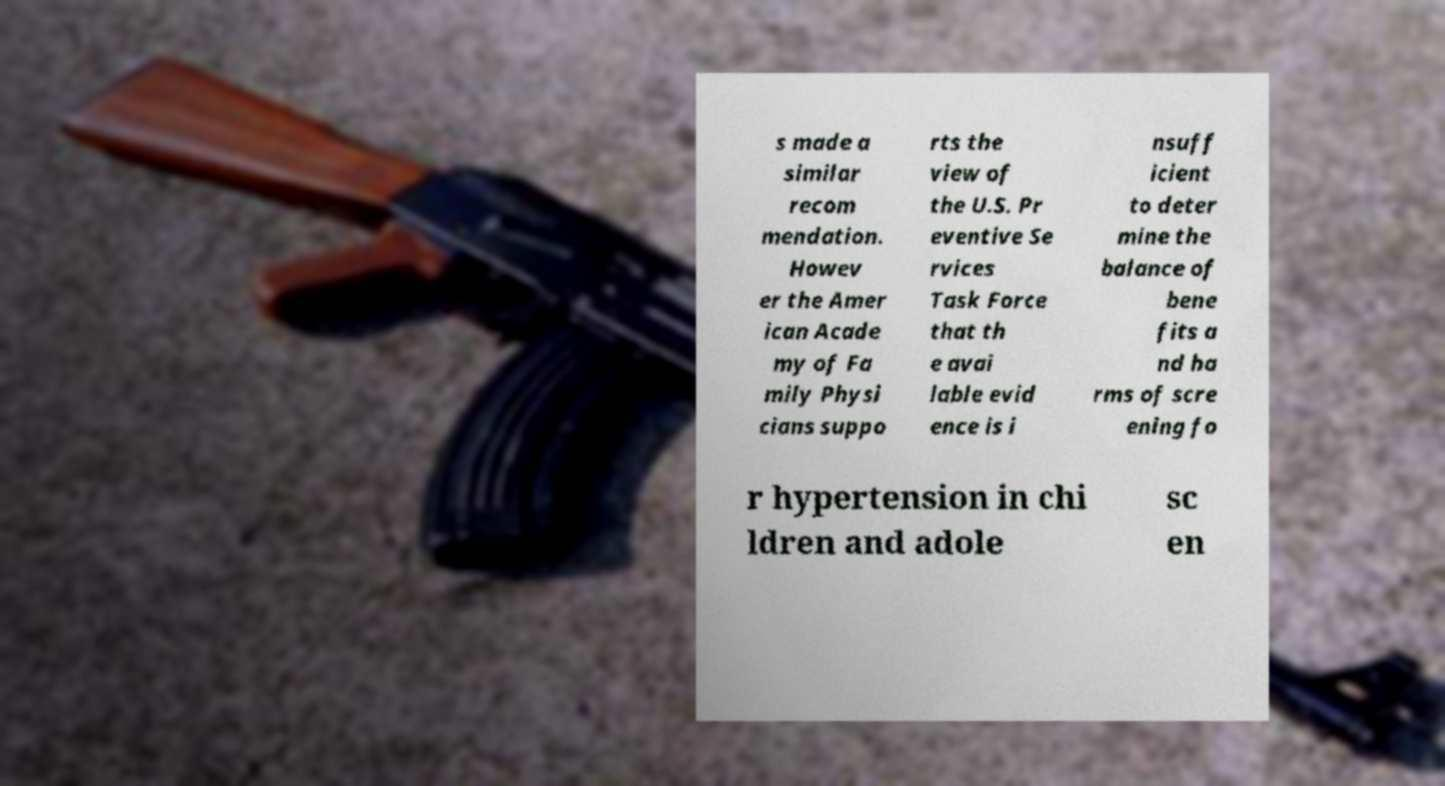Could you extract and type out the text from this image? s made a similar recom mendation. Howev er the Amer ican Acade my of Fa mily Physi cians suppo rts the view of the U.S. Pr eventive Se rvices Task Force that th e avai lable evid ence is i nsuff icient to deter mine the balance of bene fits a nd ha rms of scre ening fo r hypertension in chi ldren and adole sc en 